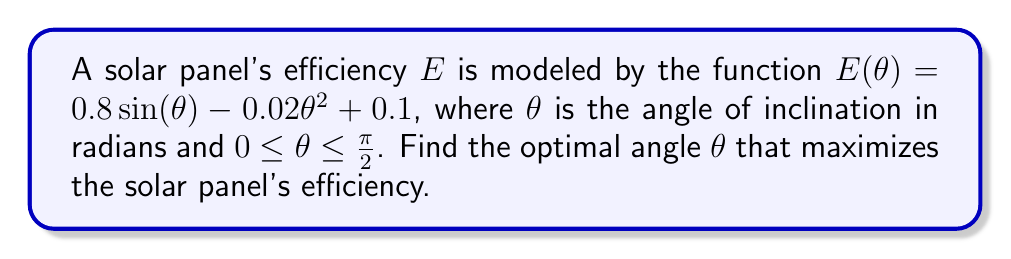Help me with this question. To find the optimal angle that maximizes the solar panel's efficiency, we need to find the maximum point of the function $E(θ)$. This can be done by following these steps:

1) First, we take the derivative of $E(θ)$ with respect to $θ$:

   $$\frac{dE}{dθ} = 0.8 \cos(θ) - 0.04θ$$

2) To find the maximum point, we set the derivative equal to zero and solve for $θ$:

   $$0.8 \cos(θ) - 0.04θ = 0$$

3) This equation cannot be solved algebraically. We need to use numerical methods or a graphing calculator to find the solution.

4) Using a numerical method (e.g., Newton's method) or a graphing calculator, we find that the equation is satisfied when:

   $$θ \approx 0.9553 \text{ radians}$$

5) To confirm this is a maximum (not a minimum), we can check the second derivative:

   $$\frac{d^2E}{dθ^2} = -0.8 \sin(θ) - 0.04$$

   At $θ = 0.9553$, this is negative, confirming a maximum.

6) Convert the result to degrees:

   $$0.9553 \text{ radians} \times \frac{180°}{\pi} \approx 54.74°$$

Therefore, the optimal angle for maximum solar panel efficiency is approximately 54.74°.
Answer: 54.74° 